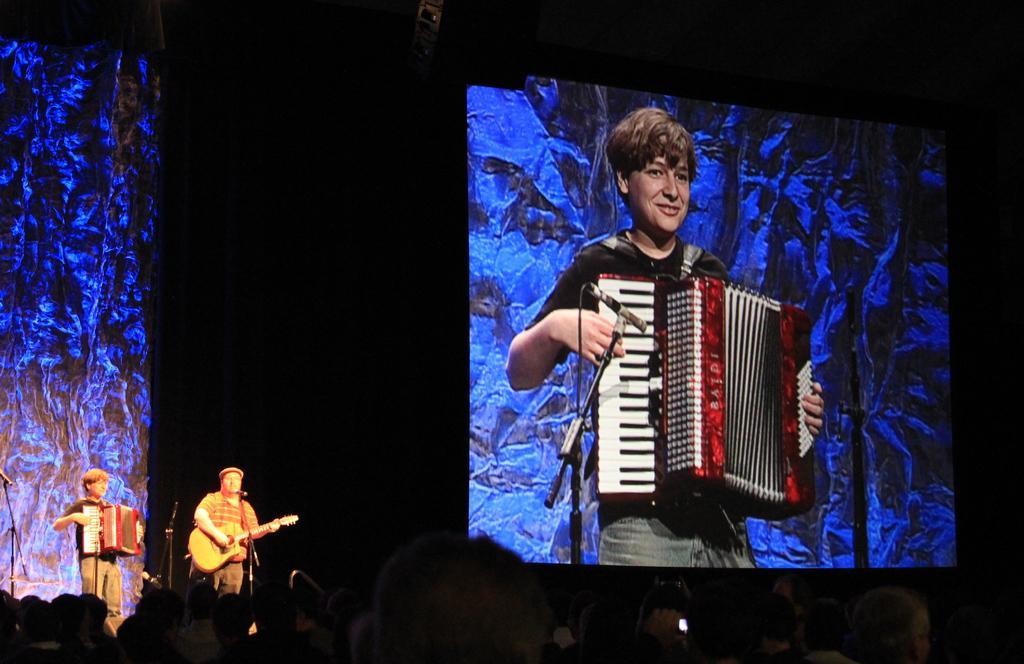Could you give a brief overview of what you see in this image? On the background we can see a screen and a person playing musical instrument. Here we can see two persons standing in front of a mike and playing musical instruments. 